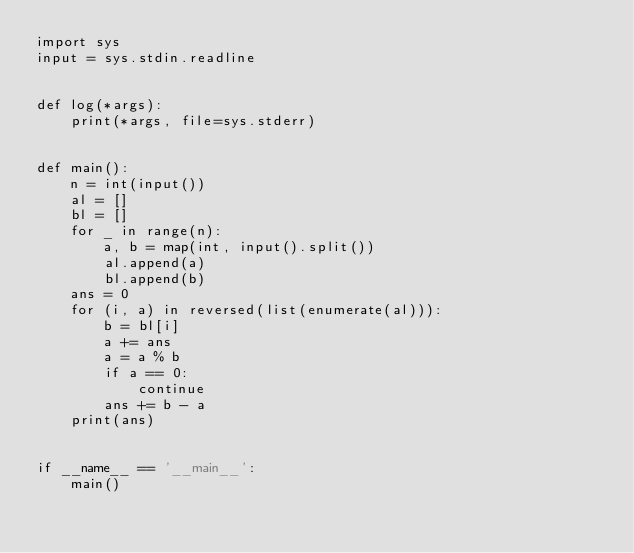Convert code to text. <code><loc_0><loc_0><loc_500><loc_500><_Python_>import sys
input = sys.stdin.readline


def log(*args):
    print(*args, file=sys.stderr)


def main():
    n = int(input())
    al = []
    bl = []
    for _ in range(n):
        a, b = map(int, input().split())
        al.append(a)
        bl.append(b)
    ans = 0
    for (i, a) in reversed(list(enumerate(al))):
        b = bl[i]
        a += ans
        a = a % b
        if a == 0:
            continue
        ans += b - a
    print(ans)


if __name__ == '__main__':
    main()
</code> 